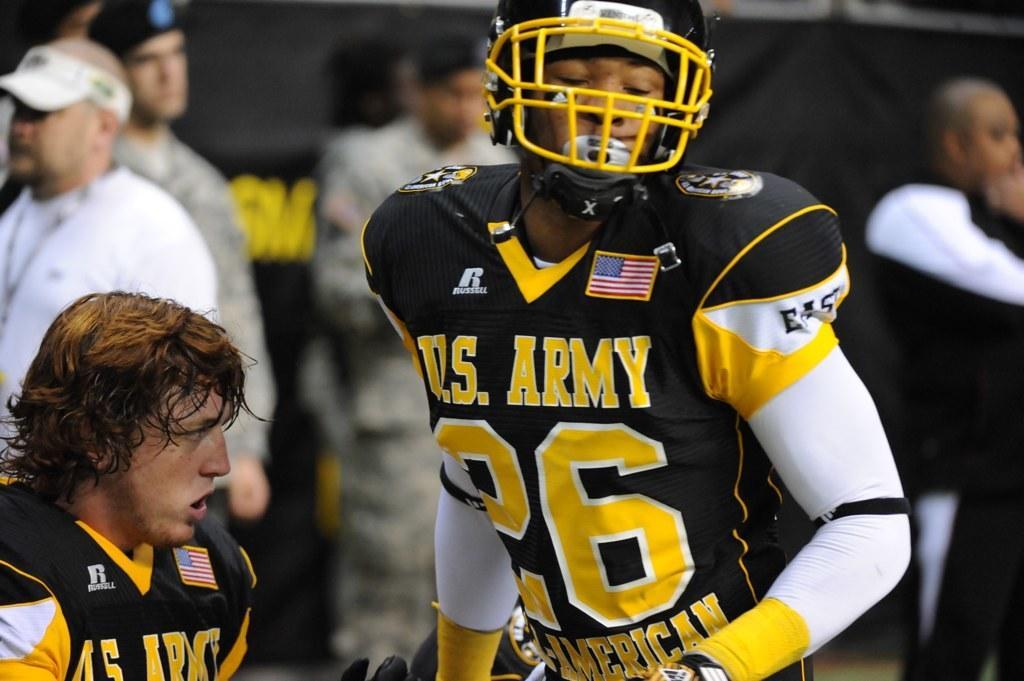Describe this image in one or two sentences. In this image we can say this person wearing black T-shirt and helmet is standing and here we can see another person. The background of the image is slightly blurred, where we can see a few more people. 